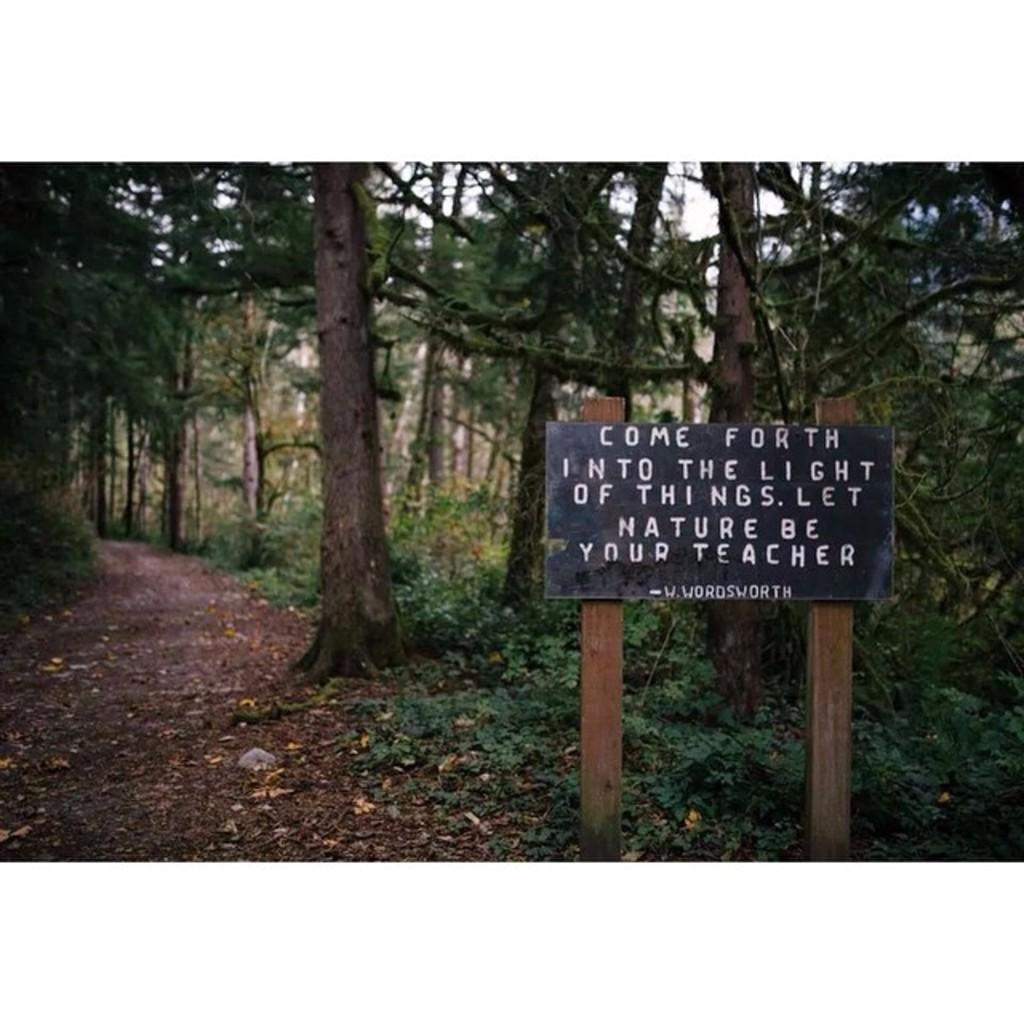What is the main object in the image that provides information or direction? There is a sign board in the image. What type of natural vegetation is visible in the image? There are trees in the image. What part of the natural environment is visible in the image? The sky is visible in the image. Where is the basin located in the image? There is no basin present in the image. What type of error can be seen on the sign board in the image? There is no error visible on the sign board in the image. Can you tell me who the mother is in the image? There is no reference to a mother or any people in the image. 